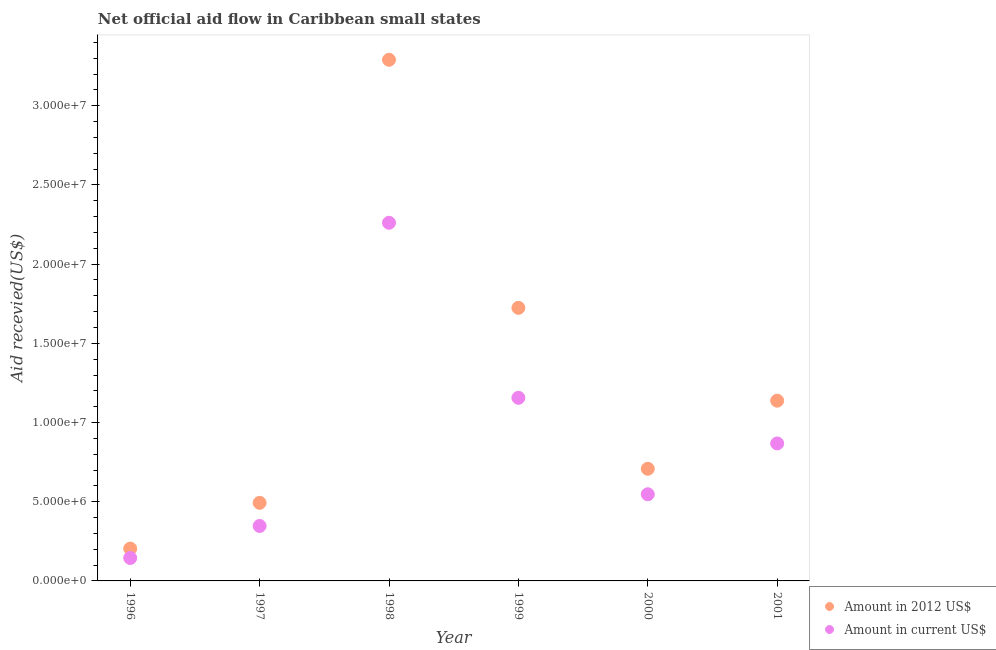How many different coloured dotlines are there?
Provide a succinct answer. 2. Is the number of dotlines equal to the number of legend labels?
Make the answer very short. Yes. What is the amount of aid received(expressed in us$) in 1999?
Provide a succinct answer. 1.16e+07. Across all years, what is the maximum amount of aid received(expressed in us$)?
Offer a very short reply. 2.26e+07. Across all years, what is the minimum amount of aid received(expressed in 2012 us$)?
Offer a very short reply. 2.04e+06. What is the total amount of aid received(expressed in 2012 us$) in the graph?
Provide a short and direct response. 7.56e+07. What is the difference between the amount of aid received(expressed in us$) in 1997 and that in 1999?
Offer a very short reply. -8.09e+06. What is the difference between the amount of aid received(expressed in 2012 us$) in 1998 and the amount of aid received(expressed in us$) in 2000?
Make the answer very short. 2.74e+07. What is the average amount of aid received(expressed in us$) per year?
Ensure brevity in your answer.  8.87e+06. In the year 2000, what is the difference between the amount of aid received(expressed in 2012 us$) and amount of aid received(expressed in us$)?
Keep it short and to the point. 1.61e+06. What is the ratio of the amount of aid received(expressed in us$) in 2000 to that in 2001?
Provide a succinct answer. 0.63. Is the amount of aid received(expressed in 2012 us$) in 1998 less than that in 2001?
Your answer should be compact. No. Is the difference between the amount of aid received(expressed in us$) in 1997 and 2000 greater than the difference between the amount of aid received(expressed in 2012 us$) in 1997 and 2000?
Your response must be concise. Yes. What is the difference between the highest and the second highest amount of aid received(expressed in us$)?
Your response must be concise. 1.10e+07. What is the difference between the highest and the lowest amount of aid received(expressed in us$)?
Your answer should be compact. 2.12e+07. In how many years, is the amount of aid received(expressed in us$) greater than the average amount of aid received(expressed in us$) taken over all years?
Keep it short and to the point. 2. Does the amount of aid received(expressed in us$) monotonically increase over the years?
Make the answer very short. No. Is the amount of aid received(expressed in 2012 us$) strictly greater than the amount of aid received(expressed in us$) over the years?
Keep it short and to the point. Yes. Is the amount of aid received(expressed in 2012 us$) strictly less than the amount of aid received(expressed in us$) over the years?
Offer a terse response. No. How many dotlines are there?
Your response must be concise. 2. What is the difference between two consecutive major ticks on the Y-axis?
Your answer should be very brief. 5.00e+06. Are the values on the major ticks of Y-axis written in scientific E-notation?
Ensure brevity in your answer.  Yes. Does the graph contain any zero values?
Keep it short and to the point. No. Does the graph contain grids?
Offer a very short reply. No. Where does the legend appear in the graph?
Offer a very short reply. Bottom right. How many legend labels are there?
Ensure brevity in your answer.  2. How are the legend labels stacked?
Give a very brief answer. Vertical. What is the title of the graph?
Give a very brief answer. Net official aid flow in Caribbean small states. Does "Commercial bank branches" appear as one of the legend labels in the graph?
Your response must be concise. No. What is the label or title of the Y-axis?
Provide a short and direct response. Aid recevied(US$). What is the Aid recevied(US$) of Amount in 2012 US$ in 1996?
Offer a terse response. 2.04e+06. What is the Aid recevied(US$) in Amount in current US$ in 1996?
Provide a succinct answer. 1.45e+06. What is the Aid recevied(US$) of Amount in 2012 US$ in 1997?
Your response must be concise. 4.93e+06. What is the Aid recevied(US$) of Amount in current US$ in 1997?
Your answer should be compact. 3.47e+06. What is the Aid recevied(US$) in Amount in 2012 US$ in 1998?
Provide a succinct answer. 3.29e+07. What is the Aid recevied(US$) of Amount in current US$ in 1998?
Make the answer very short. 2.26e+07. What is the Aid recevied(US$) of Amount in 2012 US$ in 1999?
Offer a very short reply. 1.72e+07. What is the Aid recevied(US$) of Amount in current US$ in 1999?
Keep it short and to the point. 1.16e+07. What is the Aid recevied(US$) of Amount in 2012 US$ in 2000?
Make the answer very short. 7.08e+06. What is the Aid recevied(US$) of Amount in current US$ in 2000?
Your answer should be very brief. 5.47e+06. What is the Aid recevied(US$) in Amount in 2012 US$ in 2001?
Your answer should be very brief. 1.14e+07. What is the Aid recevied(US$) in Amount in current US$ in 2001?
Give a very brief answer. 8.68e+06. Across all years, what is the maximum Aid recevied(US$) of Amount in 2012 US$?
Offer a terse response. 3.29e+07. Across all years, what is the maximum Aid recevied(US$) in Amount in current US$?
Your answer should be very brief. 2.26e+07. Across all years, what is the minimum Aid recevied(US$) of Amount in 2012 US$?
Your answer should be very brief. 2.04e+06. Across all years, what is the minimum Aid recevied(US$) in Amount in current US$?
Ensure brevity in your answer.  1.45e+06. What is the total Aid recevied(US$) in Amount in 2012 US$ in the graph?
Ensure brevity in your answer.  7.56e+07. What is the total Aid recevied(US$) of Amount in current US$ in the graph?
Offer a very short reply. 5.32e+07. What is the difference between the Aid recevied(US$) of Amount in 2012 US$ in 1996 and that in 1997?
Your answer should be very brief. -2.89e+06. What is the difference between the Aid recevied(US$) of Amount in current US$ in 1996 and that in 1997?
Your response must be concise. -2.02e+06. What is the difference between the Aid recevied(US$) of Amount in 2012 US$ in 1996 and that in 1998?
Ensure brevity in your answer.  -3.09e+07. What is the difference between the Aid recevied(US$) of Amount in current US$ in 1996 and that in 1998?
Provide a succinct answer. -2.12e+07. What is the difference between the Aid recevied(US$) in Amount in 2012 US$ in 1996 and that in 1999?
Provide a short and direct response. -1.52e+07. What is the difference between the Aid recevied(US$) in Amount in current US$ in 1996 and that in 1999?
Provide a short and direct response. -1.01e+07. What is the difference between the Aid recevied(US$) in Amount in 2012 US$ in 1996 and that in 2000?
Offer a terse response. -5.04e+06. What is the difference between the Aid recevied(US$) in Amount in current US$ in 1996 and that in 2000?
Ensure brevity in your answer.  -4.02e+06. What is the difference between the Aid recevied(US$) of Amount in 2012 US$ in 1996 and that in 2001?
Your answer should be compact. -9.34e+06. What is the difference between the Aid recevied(US$) of Amount in current US$ in 1996 and that in 2001?
Offer a terse response. -7.23e+06. What is the difference between the Aid recevied(US$) of Amount in 2012 US$ in 1997 and that in 1998?
Offer a terse response. -2.80e+07. What is the difference between the Aid recevied(US$) of Amount in current US$ in 1997 and that in 1998?
Ensure brevity in your answer.  -1.91e+07. What is the difference between the Aid recevied(US$) in Amount in 2012 US$ in 1997 and that in 1999?
Keep it short and to the point. -1.23e+07. What is the difference between the Aid recevied(US$) of Amount in current US$ in 1997 and that in 1999?
Offer a very short reply. -8.09e+06. What is the difference between the Aid recevied(US$) in Amount in 2012 US$ in 1997 and that in 2000?
Your answer should be very brief. -2.15e+06. What is the difference between the Aid recevied(US$) in Amount in 2012 US$ in 1997 and that in 2001?
Offer a very short reply. -6.45e+06. What is the difference between the Aid recevied(US$) of Amount in current US$ in 1997 and that in 2001?
Give a very brief answer. -5.21e+06. What is the difference between the Aid recevied(US$) in Amount in 2012 US$ in 1998 and that in 1999?
Your answer should be compact. 1.57e+07. What is the difference between the Aid recevied(US$) of Amount in current US$ in 1998 and that in 1999?
Ensure brevity in your answer.  1.10e+07. What is the difference between the Aid recevied(US$) of Amount in 2012 US$ in 1998 and that in 2000?
Make the answer very short. 2.58e+07. What is the difference between the Aid recevied(US$) of Amount in current US$ in 1998 and that in 2000?
Keep it short and to the point. 1.71e+07. What is the difference between the Aid recevied(US$) in Amount in 2012 US$ in 1998 and that in 2001?
Your answer should be very brief. 2.15e+07. What is the difference between the Aid recevied(US$) in Amount in current US$ in 1998 and that in 2001?
Provide a succinct answer. 1.39e+07. What is the difference between the Aid recevied(US$) in Amount in 2012 US$ in 1999 and that in 2000?
Your answer should be very brief. 1.02e+07. What is the difference between the Aid recevied(US$) of Amount in current US$ in 1999 and that in 2000?
Give a very brief answer. 6.09e+06. What is the difference between the Aid recevied(US$) of Amount in 2012 US$ in 1999 and that in 2001?
Provide a short and direct response. 5.86e+06. What is the difference between the Aid recevied(US$) of Amount in current US$ in 1999 and that in 2001?
Offer a terse response. 2.88e+06. What is the difference between the Aid recevied(US$) of Amount in 2012 US$ in 2000 and that in 2001?
Give a very brief answer. -4.30e+06. What is the difference between the Aid recevied(US$) of Amount in current US$ in 2000 and that in 2001?
Keep it short and to the point. -3.21e+06. What is the difference between the Aid recevied(US$) of Amount in 2012 US$ in 1996 and the Aid recevied(US$) of Amount in current US$ in 1997?
Offer a very short reply. -1.43e+06. What is the difference between the Aid recevied(US$) in Amount in 2012 US$ in 1996 and the Aid recevied(US$) in Amount in current US$ in 1998?
Make the answer very short. -2.06e+07. What is the difference between the Aid recevied(US$) of Amount in 2012 US$ in 1996 and the Aid recevied(US$) of Amount in current US$ in 1999?
Make the answer very short. -9.52e+06. What is the difference between the Aid recevied(US$) of Amount in 2012 US$ in 1996 and the Aid recevied(US$) of Amount in current US$ in 2000?
Offer a very short reply. -3.43e+06. What is the difference between the Aid recevied(US$) in Amount in 2012 US$ in 1996 and the Aid recevied(US$) in Amount in current US$ in 2001?
Ensure brevity in your answer.  -6.64e+06. What is the difference between the Aid recevied(US$) in Amount in 2012 US$ in 1997 and the Aid recevied(US$) in Amount in current US$ in 1998?
Your answer should be very brief. -1.77e+07. What is the difference between the Aid recevied(US$) in Amount in 2012 US$ in 1997 and the Aid recevied(US$) in Amount in current US$ in 1999?
Offer a very short reply. -6.63e+06. What is the difference between the Aid recevied(US$) in Amount in 2012 US$ in 1997 and the Aid recevied(US$) in Amount in current US$ in 2000?
Provide a succinct answer. -5.40e+05. What is the difference between the Aid recevied(US$) in Amount in 2012 US$ in 1997 and the Aid recevied(US$) in Amount in current US$ in 2001?
Make the answer very short. -3.75e+06. What is the difference between the Aid recevied(US$) of Amount in 2012 US$ in 1998 and the Aid recevied(US$) of Amount in current US$ in 1999?
Provide a succinct answer. 2.13e+07. What is the difference between the Aid recevied(US$) in Amount in 2012 US$ in 1998 and the Aid recevied(US$) in Amount in current US$ in 2000?
Your answer should be compact. 2.74e+07. What is the difference between the Aid recevied(US$) of Amount in 2012 US$ in 1998 and the Aid recevied(US$) of Amount in current US$ in 2001?
Your answer should be very brief. 2.42e+07. What is the difference between the Aid recevied(US$) of Amount in 2012 US$ in 1999 and the Aid recevied(US$) of Amount in current US$ in 2000?
Offer a terse response. 1.18e+07. What is the difference between the Aid recevied(US$) in Amount in 2012 US$ in 1999 and the Aid recevied(US$) in Amount in current US$ in 2001?
Your response must be concise. 8.56e+06. What is the difference between the Aid recevied(US$) of Amount in 2012 US$ in 2000 and the Aid recevied(US$) of Amount in current US$ in 2001?
Provide a short and direct response. -1.60e+06. What is the average Aid recevied(US$) of Amount in 2012 US$ per year?
Make the answer very short. 1.26e+07. What is the average Aid recevied(US$) of Amount in current US$ per year?
Give a very brief answer. 8.87e+06. In the year 1996, what is the difference between the Aid recevied(US$) of Amount in 2012 US$ and Aid recevied(US$) of Amount in current US$?
Offer a very short reply. 5.90e+05. In the year 1997, what is the difference between the Aid recevied(US$) of Amount in 2012 US$ and Aid recevied(US$) of Amount in current US$?
Make the answer very short. 1.46e+06. In the year 1998, what is the difference between the Aid recevied(US$) in Amount in 2012 US$ and Aid recevied(US$) in Amount in current US$?
Provide a short and direct response. 1.03e+07. In the year 1999, what is the difference between the Aid recevied(US$) in Amount in 2012 US$ and Aid recevied(US$) in Amount in current US$?
Ensure brevity in your answer.  5.68e+06. In the year 2000, what is the difference between the Aid recevied(US$) of Amount in 2012 US$ and Aid recevied(US$) of Amount in current US$?
Provide a succinct answer. 1.61e+06. In the year 2001, what is the difference between the Aid recevied(US$) of Amount in 2012 US$ and Aid recevied(US$) of Amount in current US$?
Your response must be concise. 2.70e+06. What is the ratio of the Aid recevied(US$) in Amount in 2012 US$ in 1996 to that in 1997?
Your answer should be very brief. 0.41. What is the ratio of the Aid recevied(US$) in Amount in current US$ in 1996 to that in 1997?
Provide a succinct answer. 0.42. What is the ratio of the Aid recevied(US$) in Amount in 2012 US$ in 1996 to that in 1998?
Provide a succinct answer. 0.06. What is the ratio of the Aid recevied(US$) of Amount in current US$ in 1996 to that in 1998?
Provide a succinct answer. 0.06. What is the ratio of the Aid recevied(US$) in Amount in 2012 US$ in 1996 to that in 1999?
Ensure brevity in your answer.  0.12. What is the ratio of the Aid recevied(US$) of Amount in current US$ in 1996 to that in 1999?
Provide a succinct answer. 0.13. What is the ratio of the Aid recevied(US$) in Amount in 2012 US$ in 1996 to that in 2000?
Offer a very short reply. 0.29. What is the ratio of the Aid recevied(US$) in Amount in current US$ in 1996 to that in 2000?
Your response must be concise. 0.27. What is the ratio of the Aid recevied(US$) of Amount in 2012 US$ in 1996 to that in 2001?
Give a very brief answer. 0.18. What is the ratio of the Aid recevied(US$) of Amount in current US$ in 1996 to that in 2001?
Ensure brevity in your answer.  0.17. What is the ratio of the Aid recevied(US$) in Amount in 2012 US$ in 1997 to that in 1998?
Keep it short and to the point. 0.15. What is the ratio of the Aid recevied(US$) in Amount in current US$ in 1997 to that in 1998?
Offer a very short reply. 0.15. What is the ratio of the Aid recevied(US$) of Amount in 2012 US$ in 1997 to that in 1999?
Make the answer very short. 0.29. What is the ratio of the Aid recevied(US$) in Amount in current US$ in 1997 to that in 1999?
Keep it short and to the point. 0.3. What is the ratio of the Aid recevied(US$) in Amount in 2012 US$ in 1997 to that in 2000?
Keep it short and to the point. 0.7. What is the ratio of the Aid recevied(US$) of Amount in current US$ in 1997 to that in 2000?
Make the answer very short. 0.63. What is the ratio of the Aid recevied(US$) of Amount in 2012 US$ in 1997 to that in 2001?
Your response must be concise. 0.43. What is the ratio of the Aid recevied(US$) of Amount in current US$ in 1997 to that in 2001?
Your answer should be very brief. 0.4. What is the ratio of the Aid recevied(US$) of Amount in 2012 US$ in 1998 to that in 1999?
Offer a very short reply. 1.91. What is the ratio of the Aid recevied(US$) in Amount in current US$ in 1998 to that in 1999?
Your answer should be very brief. 1.96. What is the ratio of the Aid recevied(US$) in Amount in 2012 US$ in 1998 to that in 2000?
Offer a terse response. 4.65. What is the ratio of the Aid recevied(US$) in Amount in current US$ in 1998 to that in 2000?
Ensure brevity in your answer.  4.13. What is the ratio of the Aid recevied(US$) of Amount in 2012 US$ in 1998 to that in 2001?
Offer a terse response. 2.89. What is the ratio of the Aid recevied(US$) of Amount in current US$ in 1998 to that in 2001?
Ensure brevity in your answer.  2.6. What is the ratio of the Aid recevied(US$) in Amount in 2012 US$ in 1999 to that in 2000?
Your answer should be very brief. 2.44. What is the ratio of the Aid recevied(US$) of Amount in current US$ in 1999 to that in 2000?
Provide a succinct answer. 2.11. What is the ratio of the Aid recevied(US$) of Amount in 2012 US$ in 1999 to that in 2001?
Your response must be concise. 1.51. What is the ratio of the Aid recevied(US$) in Amount in current US$ in 1999 to that in 2001?
Provide a short and direct response. 1.33. What is the ratio of the Aid recevied(US$) of Amount in 2012 US$ in 2000 to that in 2001?
Provide a succinct answer. 0.62. What is the ratio of the Aid recevied(US$) in Amount in current US$ in 2000 to that in 2001?
Provide a succinct answer. 0.63. What is the difference between the highest and the second highest Aid recevied(US$) of Amount in 2012 US$?
Offer a terse response. 1.57e+07. What is the difference between the highest and the second highest Aid recevied(US$) in Amount in current US$?
Offer a terse response. 1.10e+07. What is the difference between the highest and the lowest Aid recevied(US$) of Amount in 2012 US$?
Your answer should be very brief. 3.09e+07. What is the difference between the highest and the lowest Aid recevied(US$) of Amount in current US$?
Your response must be concise. 2.12e+07. 